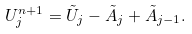<formula> <loc_0><loc_0><loc_500><loc_500>U _ { j } ^ { n + 1 } = \tilde { U } _ { j } - \tilde { A } _ { j } + \tilde { A } _ { j - 1 } .</formula> 